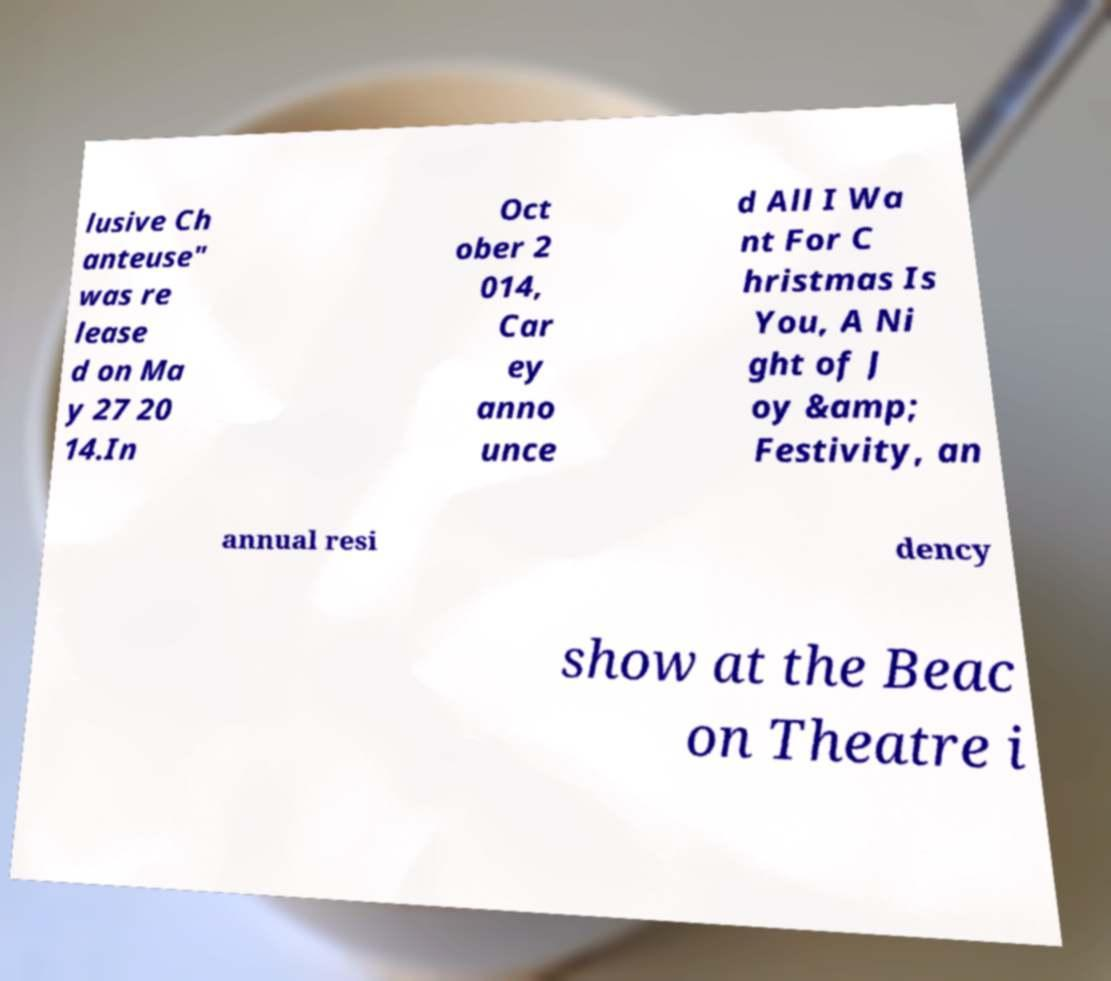Can you accurately transcribe the text from the provided image for me? lusive Ch anteuse" was re lease d on Ma y 27 20 14.In Oct ober 2 014, Car ey anno unce d All I Wa nt For C hristmas Is You, A Ni ght of J oy &amp; Festivity, an annual resi dency show at the Beac on Theatre i 